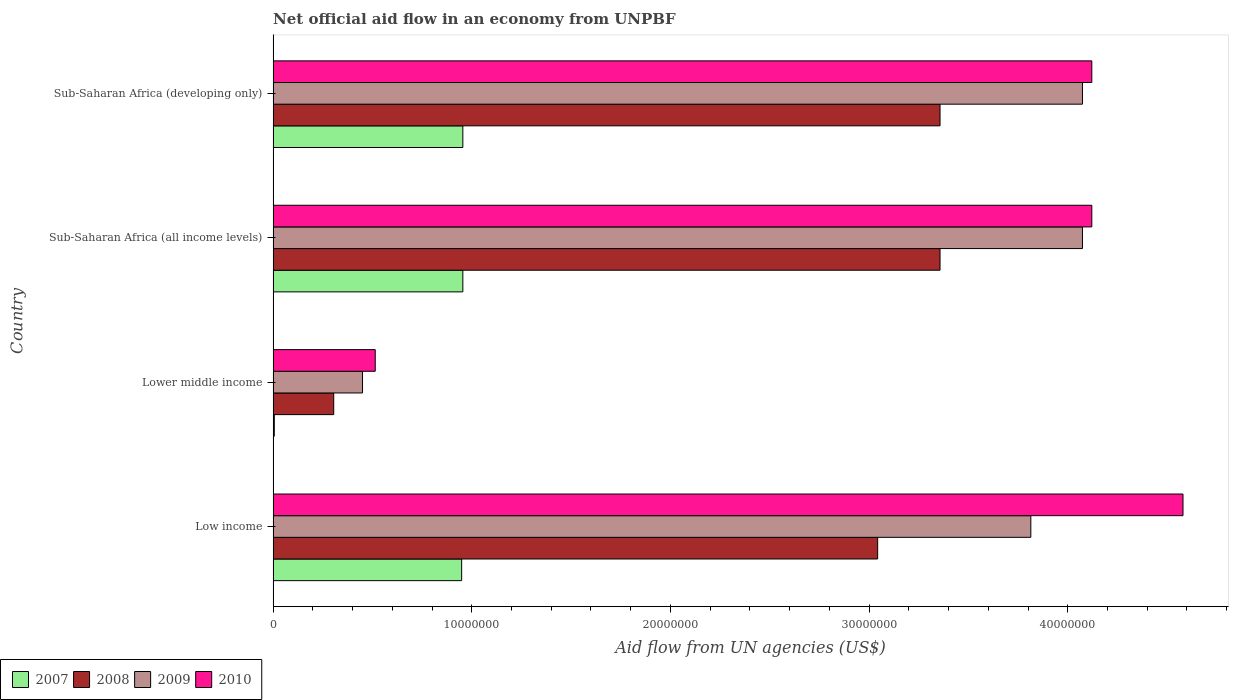How many different coloured bars are there?
Ensure brevity in your answer.  4. How many groups of bars are there?
Provide a short and direct response. 4. Are the number of bars per tick equal to the number of legend labels?
Your answer should be very brief. Yes. Are the number of bars on each tick of the Y-axis equal?
Your answer should be compact. Yes. How many bars are there on the 1st tick from the top?
Make the answer very short. 4. How many bars are there on the 2nd tick from the bottom?
Ensure brevity in your answer.  4. What is the label of the 4th group of bars from the top?
Offer a very short reply. Low income. In how many cases, is the number of bars for a given country not equal to the number of legend labels?
Your answer should be compact. 0. What is the net official aid flow in 2009 in Sub-Saharan Africa (all income levels)?
Offer a terse response. 4.07e+07. Across all countries, what is the maximum net official aid flow in 2010?
Ensure brevity in your answer.  4.58e+07. Across all countries, what is the minimum net official aid flow in 2008?
Offer a very short reply. 3.05e+06. In which country was the net official aid flow in 2008 maximum?
Provide a succinct answer. Sub-Saharan Africa (all income levels). In which country was the net official aid flow in 2008 minimum?
Offer a terse response. Lower middle income. What is the total net official aid flow in 2009 in the graph?
Offer a terse response. 1.24e+08. What is the difference between the net official aid flow in 2007 in Lower middle income and that in Sub-Saharan Africa (developing only)?
Make the answer very short. -9.49e+06. What is the difference between the net official aid flow in 2007 in Lower middle income and the net official aid flow in 2009 in Low income?
Offer a very short reply. -3.81e+07. What is the average net official aid flow in 2010 per country?
Offer a very short reply. 3.33e+07. What is the difference between the net official aid flow in 2009 and net official aid flow in 2007 in Lower middle income?
Make the answer very short. 4.44e+06. In how many countries, is the net official aid flow in 2010 greater than 40000000 US$?
Provide a short and direct response. 3. What is the ratio of the net official aid flow in 2008 in Sub-Saharan Africa (all income levels) to that in Sub-Saharan Africa (developing only)?
Your response must be concise. 1. Is the net official aid flow in 2010 in Sub-Saharan Africa (all income levels) less than that in Sub-Saharan Africa (developing only)?
Ensure brevity in your answer.  No. What is the difference between the highest and the lowest net official aid flow in 2009?
Your answer should be very brief. 3.62e+07. In how many countries, is the net official aid flow in 2008 greater than the average net official aid flow in 2008 taken over all countries?
Give a very brief answer. 3. Is it the case that in every country, the sum of the net official aid flow in 2007 and net official aid flow in 2008 is greater than the sum of net official aid flow in 2009 and net official aid flow in 2010?
Keep it short and to the point. No. Is it the case that in every country, the sum of the net official aid flow in 2010 and net official aid flow in 2007 is greater than the net official aid flow in 2008?
Offer a very short reply. Yes. How many bars are there?
Give a very brief answer. 16. Are all the bars in the graph horizontal?
Ensure brevity in your answer.  Yes. What is the difference between two consecutive major ticks on the X-axis?
Offer a terse response. 1.00e+07. Are the values on the major ticks of X-axis written in scientific E-notation?
Keep it short and to the point. No. Does the graph contain grids?
Give a very brief answer. No. What is the title of the graph?
Your answer should be very brief. Net official aid flow in an economy from UNPBF. What is the label or title of the X-axis?
Provide a succinct answer. Aid flow from UN agencies (US$). What is the Aid flow from UN agencies (US$) of 2007 in Low income?
Offer a terse response. 9.49e+06. What is the Aid flow from UN agencies (US$) in 2008 in Low income?
Provide a short and direct response. 3.04e+07. What is the Aid flow from UN agencies (US$) of 2009 in Low income?
Provide a succinct answer. 3.81e+07. What is the Aid flow from UN agencies (US$) of 2010 in Low income?
Make the answer very short. 4.58e+07. What is the Aid flow from UN agencies (US$) in 2007 in Lower middle income?
Your answer should be very brief. 6.00e+04. What is the Aid flow from UN agencies (US$) in 2008 in Lower middle income?
Keep it short and to the point. 3.05e+06. What is the Aid flow from UN agencies (US$) in 2009 in Lower middle income?
Offer a very short reply. 4.50e+06. What is the Aid flow from UN agencies (US$) in 2010 in Lower middle income?
Offer a terse response. 5.14e+06. What is the Aid flow from UN agencies (US$) of 2007 in Sub-Saharan Africa (all income levels)?
Keep it short and to the point. 9.55e+06. What is the Aid flow from UN agencies (US$) in 2008 in Sub-Saharan Africa (all income levels)?
Make the answer very short. 3.36e+07. What is the Aid flow from UN agencies (US$) of 2009 in Sub-Saharan Africa (all income levels)?
Give a very brief answer. 4.07e+07. What is the Aid flow from UN agencies (US$) in 2010 in Sub-Saharan Africa (all income levels)?
Your answer should be compact. 4.12e+07. What is the Aid flow from UN agencies (US$) of 2007 in Sub-Saharan Africa (developing only)?
Your answer should be compact. 9.55e+06. What is the Aid flow from UN agencies (US$) in 2008 in Sub-Saharan Africa (developing only)?
Your response must be concise. 3.36e+07. What is the Aid flow from UN agencies (US$) of 2009 in Sub-Saharan Africa (developing only)?
Provide a short and direct response. 4.07e+07. What is the Aid flow from UN agencies (US$) of 2010 in Sub-Saharan Africa (developing only)?
Make the answer very short. 4.12e+07. Across all countries, what is the maximum Aid flow from UN agencies (US$) in 2007?
Ensure brevity in your answer.  9.55e+06. Across all countries, what is the maximum Aid flow from UN agencies (US$) of 2008?
Your answer should be very brief. 3.36e+07. Across all countries, what is the maximum Aid flow from UN agencies (US$) of 2009?
Your answer should be compact. 4.07e+07. Across all countries, what is the maximum Aid flow from UN agencies (US$) in 2010?
Give a very brief answer. 4.58e+07. Across all countries, what is the minimum Aid flow from UN agencies (US$) in 2008?
Keep it short and to the point. 3.05e+06. Across all countries, what is the minimum Aid flow from UN agencies (US$) of 2009?
Offer a very short reply. 4.50e+06. Across all countries, what is the minimum Aid flow from UN agencies (US$) of 2010?
Keep it short and to the point. 5.14e+06. What is the total Aid flow from UN agencies (US$) of 2007 in the graph?
Ensure brevity in your answer.  2.86e+07. What is the total Aid flow from UN agencies (US$) of 2008 in the graph?
Provide a succinct answer. 1.01e+08. What is the total Aid flow from UN agencies (US$) of 2009 in the graph?
Offer a terse response. 1.24e+08. What is the total Aid flow from UN agencies (US$) in 2010 in the graph?
Provide a succinct answer. 1.33e+08. What is the difference between the Aid flow from UN agencies (US$) of 2007 in Low income and that in Lower middle income?
Your response must be concise. 9.43e+06. What is the difference between the Aid flow from UN agencies (US$) of 2008 in Low income and that in Lower middle income?
Offer a very short reply. 2.74e+07. What is the difference between the Aid flow from UN agencies (US$) of 2009 in Low income and that in Lower middle income?
Ensure brevity in your answer.  3.36e+07. What is the difference between the Aid flow from UN agencies (US$) in 2010 in Low income and that in Lower middle income?
Make the answer very short. 4.07e+07. What is the difference between the Aid flow from UN agencies (US$) in 2008 in Low income and that in Sub-Saharan Africa (all income levels)?
Provide a succinct answer. -3.14e+06. What is the difference between the Aid flow from UN agencies (US$) of 2009 in Low income and that in Sub-Saharan Africa (all income levels)?
Ensure brevity in your answer.  -2.60e+06. What is the difference between the Aid flow from UN agencies (US$) of 2010 in Low income and that in Sub-Saharan Africa (all income levels)?
Your answer should be very brief. 4.59e+06. What is the difference between the Aid flow from UN agencies (US$) in 2007 in Low income and that in Sub-Saharan Africa (developing only)?
Give a very brief answer. -6.00e+04. What is the difference between the Aid flow from UN agencies (US$) in 2008 in Low income and that in Sub-Saharan Africa (developing only)?
Provide a succinct answer. -3.14e+06. What is the difference between the Aid flow from UN agencies (US$) of 2009 in Low income and that in Sub-Saharan Africa (developing only)?
Keep it short and to the point. -2.60e+06. What is the difference between the Aid flow from UN agencies (US$) in 2010 in Low income and that in Sub-Saharan Africa (developing only)?
Provide a short and direct response. 4.59e+06. What is the difference between the Aid flow from UN agencies (US$) of 2007 in Lower middle income and that in Sub-Saharan Africa (all income levels)?
Provide a succinct answer. -9.49e+06. What is the difference between the Aid flow from UN agencies (US$) of 2008 in Lower middle income and that in Sub-Saharan Africa (all income levels)?
Ensure brevity in your answer.  -3.05e+07. What is the difference between the Aid flow from UN agencies (US$) in 2009 in Lower middle income and that in Sub-Saharan Africa (all income levels)?
Make the answer very short. -3.62e+07. What is the difference between the Aid flow from UN agencies (US$) in 2010 in Lower middle income and that in Sub-Saharan Africa (all income levels)?
Your answer should be very brief. -3.61e+07. What is the difference between the Aid flow from UN agencies (US$) of 2007 in Lower middle income and that in Sub-Saharan Africa (developing only)?
Provide a short and direct response. -9.49e+06. What is the difference between the Aid flow from UN agencies (US$) in 2008 in Lower middle income and that in Sub-Saharan Africa (developing only)?
Your response must be concise. -3.05e+07. What is the difference between the Aid flow from UN agencies (US$) in 2009 in Lower middle income and that in Sub-Saharan Africa (developing only)?
Ensure brevity in your answer.  -3.62e+07. What is the difference between the Aid flow from UN agencies (US$) of 2010 in Lower middle income and that in Sub-Saharan Africa (developing only)?
Provide a succinct answer. -3.61e+07. What is the difference between the Aid flow from UN agencies (US$) in 2007 in Low income and the Aid flow from UN agencies (US$) in 2008 in Lower middle income?
Keep it short and to the point. 6.44e+06. What is the difference between the Aid flow from UN agencies (US$) in 2007 in Low income and the Aid flow from UN agencies (US$) in 2009 in Lower middle income?
Offer a very short reply. 4.99e+06. What is the difference between the Aid flow from UN agencies (US$) in 2007 in Low income and the Aid flow from UN agencies (US$) in 2010 in Lower middle income?
Give a very brief answer. 4.35e+06. What is the difference between the Aid flow from UN agencies (US$) in 2008 in Low income and the Aid flow from UN agencies (US$) in 2009 in Lower middle income?
Provide a succinct answer. 2.59e+07. What is the difference between the Aid flow from UN agencies (US$) of 2008 in Low income and the Aid flow from UN agencies (US$) of 2010 in Lower middle income?
Your response must be concise. 2.53e+07. What is the difference between the Aid flow from UN agencies (US$) of 2009 in Low income and the Aid flow from UN agencies (US$) of 2010 in Lower middle income?
Give a very brief answer. 3.30e+07. What is the difference between the Aid flow from UN agencies (US$) in 2007 in Low income and the Aid flow from UN agencies (US$) in 2008 in Sub-Saharan Africa (all income levels)?
Offer a terse response. -2.41e+07. What is the difference between the Aid flow from UN agencies (US$) of 2007 in Low income and the Aid flow from UN agencies (US$) of 2009 in Sub-Saharan Africa (all income levels)?
Make the answer very short. -3.12e+07. What is the difference between the Aid flow from UN agencies (US$) in 2007 in Low income and the Aid flow from UN agencies (US$) in 2010 in Sub-Saharan Africa (all income levels)?
Provide a short and direct response. -3.17e+07. What is the difference between the Aid flow from UN agencies (US$) of 2008 in Low income and the Aid flow from UN agencies (US$) of 2009 in Sub-Saharan Africa (all income levels)?
Give a very brief answer. -1.03e+07. What is the difference between the Aid flow from UN agencies (US$) in 2008 in Low income and the Aid flow from UN agencies (US$) in 2010 in Sub-Saharan Africa (all income levels)?
Your answer should be compact. -1.08e+07. What is the difference between the Aid flow from UN agencies (US$) of 2009 in Low income and the Aid flow from UN agencies (US$) of 2010 in Sub-Saharan Africa (all income levels)?
Your response must be concise. -3.07e+06. What is the difference between the Aid flow from UN agencies (US$) in 2007 in Low income and the Aid flow from UN agencies (US$) in 2008 in Sub-Saharan Africa (developing only)?
Your response must be concise. -2.41e+07. What is the difference between the Aid flow from UN agencies (US$) of 2007 in Low income and the Aid flow from UN agencies (US$) of 2009 in Sub-Saharan Africa (developing only)?
Provide a short and direct response. -3.12e+07. What is the difference between the Aid flow from UN agencies (US$) of 2007 in Low income and the Aid flow from UN agencies (US$) of 2010 in Sub-Saharan Africa (developing only)?
Your response must be concise. -3.17e+07. What is the difference between the Aid flow from UN agencies (US$) in 2008 in Low income and the Aid flow from UN agencies (US$) in 2009 in Sub-Saharan Africa (developing only)?
Your answer should be very brief. -1.03e+07. What is the difference between the Aid flow from UN agencies (US$) of 2008 in Low income and the Aid flow from UN agencies (US$) of 2010 in Sub-Saharan Africa (developing only)?
Provide a succinct answer. -1.08e+07. What is the difference between the Aid flow from UN agencies (US$) of 2009 in Low income and the Aid flow from UN agencies (US$) of 2010 in Sub-Saharan Africa (developing only)?
Provide a short and direct response. -3.07e+06. What is the difference between the Aid flow from UN agencies (US$) of 2007 in Lower middle income and the Aid flow from UN agencies (US$) of 2008 in Sub-Saharan Africa (all income levels)?
Your answer should be compact. -3.35e+07. What is the difference between the Aid flow from UN agencies (US$) in 2007 in Lower middle income and the Aid flow from UN agencies (US$) in 2009 in Sub-Saharan Africa (all income levels)?
Your answer should be compact. -4.07e+07. What is the difference between the Aid flow from UN agencies (US$) of 2007 in Lower middle income and the Aid flow from UN agencies (US$) of 2010 in Sub-Saharan Africa (all income levels)?
Your answer should be very brief. -4.12e+07. What is the difference between the Aid flow from UN agencies (US$) of 2008 in Lower middle income and the Aid flow from UN agencies (US$) of 2009 in Sub-Saharan Africa (all income levels)?
Keep it short and to the point. -3.77e+07. What is the difference between the Aid flow from UN agencies (US$) in 2008 in Lower middle income and the Aid flow from UN agencies (US$) in 2010 in Sub-Saharan Africa (all income levels)?
Provide a succinct answer. -3.82e+07. What is the difference between the Aid flow from UN agencies (US$) of 2009 in Lower middle income and the Aid flow from UN agencies (US$) of 2010 in Sub-Saharan Africa (all income levels)?
Your answer should be compact. -3.67e+07. What is the difference between the Aid flow from UN agencies (US$) of 2007 in Lower middle income and the Aid flow from UN agencies (US$) of 2008 in Sub-Saharan Africa (developing only)?
Offer a very short reply. -3.35e+07. What is the difference between the Aid flow from UN agencies (US$) of 2007 in Lower middle income and the Aid flow from UN agencies (US$) of 2009 in Sub-Saharan Africa (developing only)?
Offer a very short reply. -4.07e+07. What is the difference between the Aid flow from UN agencies (US$) in 2007 in Lower middle income and the Aid flow from UN agencies (US$) in 2010 in Sub-Saharan Africa (developing only)?
Make the answer very short. -4.12e+07. What is the difference between the Aid flow from UN agencies (US$) in 2008 in Lower middle income and the Aid flow from UN agencies (US$) in 2009 in Sub-Saharan Africa (developing only)?
Your answer should be very brief. -3.77e+07. What is the difference between the Aid flow from UN agencies (US$) in 2008 in Lower middle income and the Aid flow from UN agencies (US$) in 2010 in Sub-Saharan Africa (developing only)?
Provide a succinct answer. -3.82e+07. What is the difference between the Aid flow from UN agencies (US$) of 2009 in Lower middle income and the Aid flow from UN agencies (US$) of 2010 in Sub-Saharan Africa (developing only)?
Make the answer very short. -3.67e+07. What is the difference between the Aid flow from UN agencies (US$) in 2007 in Sub-Saharan Africa (all income levels) and the Aid flow from UN agencies (US$) in 2008 in Sub-Saharan Africa (developing only)?
Provide a succinct answer. -2.40e+07. What is the difference between the Aid flow from UN agencies (US$) of 2007 in Sub-Saharan Africa (all income levels) and the Aid flow from UN agencies (US$) of 2009 in Sub-Saharan Africa (developing only)?
Provide a short and direct response. -3.12e+07. What is the difference between the Aid flow from UN agencies (US$) in 2007 in Sub-Saharan Africa (all income levels) and the Aid flow from UN agencies (US$) in 2010 in Sub-Saharan Africa (developing only)?
Provide a succinct answer. -3.17e+07. What is the difference between the Aid flow from UN agencies (US$) in 2008 in Sub-Saharan Africa (all income levels) and the Aid flow from UN agencies (US$) in 2009 in Sub-Saharan Africa (developing only)?
Provide a succinct answer. -7.17e+06. What is the difference between the Aid flow from UN agencies (US$) in 2008 in Sub-Saharan Africa (all income levels) and the Aid flow from UN agencies (US$) in 2010 in Sub-Saharan Africa (developing only)?
Your response must be concise. -7.64e+06. What is the difference between the Aid flow from UN agencies (US$) in 2009 in Sub-Saharan Africa (all income levels) and the Aid flow from UN agencies (US$) in 2010 in Sub-Saharan Africa (developing only)?
Offer a very short reply. -4.70e+05. What is the average Aid flow from UN agencies (US$) in 2007 per country?
Make the answer very short. 7.16e+06. What is the average Aid flow from UN agencies (US$) in 2008 per country?
Keep it short and to the point. 2.52e+07. What is the average Aid flow from UN agencies (US$) of 2009 per country?
Keep it short and to the point. 3.10e+07. What is the average Aid flow from UN agencies (US$) of 2010 per country?
Make the answer very short. 3.33e+07. What is the difference between the Aid flow from UN agencies (US$) of 2007 and Aid flow from UN agencies (US$) of 2008 in Low income?
Your answer should be very brief. -2.09e+07. What is the difference between the Aid flow from UN agencies (US$) of 2007 and Aid flow from UN agencies (US$) of 2009 in Low income?
Make the answer very short. -2.86e+07. What is the difference between the Aid flow from UN agencies (US$) of 2007 and Aid flow from UN agencies (US$) of 2010 in Low income?
Ensure brevity in your answer.  -3.63e+07. What is the difference between the Aid flow from UN agencies (US$) in 2008 and Aid flow from UN agencies (US$) in 2009 in Low income?
Offer a very short reply. -7.71e+06. What is the difference between the Aid flow from UN agencies (US$) of 2008 and Aid flow from UN agencies (US$) of 2010 in Low income?
Your response must be concise. -1.54e+07. What is the difference between the Aid flow from UN agencies (US$) of 2009 and Aid flow from UN agencies (US$) of 2010 in Low income?
Offer a very short reply. -7.66e+06. What is the difference between the Aid flow from UN agencies (US$) in 2007 and Aid flow from UN agencies (US$) in 2008 in Lower middle income?
Give a very brief answer. -2.99e+06. What is the difference between the Aid flow from UN agencies (US$) of 2007 and Aid flow from UN agencies (US$) of 2009 in Lower middle income?
Give a very brief answer. -4.44e+06. What is the difference between the Aid flow from UN agencies (US$) in 2007 and Aid flow from UN agencies (US$) in 2010 in Lower middle income?
Your answer should be compact. -5.08e+06. What is the difference between the Aid flow from UN agencies (US$) of 2008 and Aid flow from UN agencies (US$) of 2009 in Lower middle income?
Make the answer very short. -1.45e+06. What is the difference between the Aid flow from UN agencies (US$) in 2008 and Aid flow from UN agencies (US$) in 2010 in Lower middle income?
Offer a very short reply. -2.09e+06. What is the difference between the Aid flow from UN agencies (US$) of 2009 and Aid flow from UN agencies (US$) of 2010 in Lower middle income?
Your answer should be very brief. -6.40e+05. What is the difference between the Aid flow from UN agencies (US$) of 2007 and Aid flow from UN agencies (US$) of 2008 in Sub-Saharan Africa (all income levels)?
Offer a terse response. -2.40e+07. What is the difference between the Aid flow from UN agencies (US$) of 2007 and Aid flow from UN agencies (US$) of 2009 in Sub-Saharan Africa (all income levels)?
Give a very brief answer. -3.12e+07. What is the difference between the Aid flow from UN agencies (US$) of 2007 and Aid flow from UN agencies (US$) of 2010 in Sub-Saharan Africa (all income levels)?
Give a very brief answer. -3.17e+07. What is the difference between the Aid flow from UN agencies (US$) of 2008 and Aid flow from UN agencies (US$) of 2009 in Sub-Saharan Africa (all income levels)?
Ensure brevity in your answer.  -7.17e+06. What is the difference between the Aid flow from UN agencies (US$) of 2008 and Aid flow from UN agencies (US$) of 2010 in Sub-Saharan Africa (all income levels)?
Offer a very short reply. -7.64e+06. What is the difference between the Aid flow from UN agencies (US$) of 2009 and Aid flow from UN agencies (US$) of 2010 in Sub-Saharan Africa (all income levels)?
Give a very brief answer. -4.70e+05. What is the difference between the Aid flow from UN agencies (US$) in 2007 and Aid flow from UN agencies (US$) in 2008 in Sub-Saharan Africa (developing only)?
Ensure brevity in your answer.  -2.40e+07. What is the difference between the Aid flow from UN agencies (US$) of 2007 and Aid flow from UN agencies (US$) of 2009 in Sub-Saharan Africa (developing only)?
Your response must be concise. -3.12e+07. What is the difference between the Aid flow from UN agencies (US$) of 2007 and Aid flow from UN agencies (US$) of 2010 in Sub-Saharan Africa (developing only)?
Offer a terse response. -3.17e+07. What is the difference between the Aid flow from UN agencies (US$) in 2008 and Aid flow from UN agencies (US$) in 2009 in Sub-Saharan Africa (developing only)?
Offer a very short reply. -7.17e+06. What is the difference between the Aid flow from UN agencies (US$) in 2008 and Aid flow from UN agencies (US$) in 2010 in Sub-Saharan Africa (developing only)?
Provide a succinct answer. -7.64e+06. What is the difference between the Aid flow from UN agencies (US$) in 2009 and Aid flow from UN agencies (US$) in 2010 in Sub-Saharan Africa (developing only)?
Your answer should be compact. -4.70e+05. What is the ratio of the Aid flow from UN agencies (US$) in 2007 in Low income to that in Lower middle income?
Offer a terse response. 158.17. What is the ratio of the Aid flow from UN agencies (US$) in 2008 in Low income to that in Lower middle income?
Your response must be concise. 9.98. What is the ratio of the Aid flow from UN agencies (US$) in 2009 in Low income to that in Lower middle income?
Provide a short and direct response. 8.48. What is the ratio of the Aid flow from UN agencies (US$) of 2010 in Low income to that in Lower middle income?
Provide a short and direct response. 8.91. What is the ratio of the Aid flow from UN agencies (US$) of 2008 in Low income to that in Sub-Saharan Africa (all income levels)?
Ensure brevity in your answer.  0.91. What is the ratio of the Aid flow from UN agencies (US$) in 2009 in Low income to that in Sub-Saharan Africa (all income levels)?
Ensure brevity in your answer.  0.94. What is the ratio of the Aid flow from UN agencies (US$) in 2010 in Low income to that in Sub-Saharan Africa (all income levels)?
Provide a succinct answer. 1.11. What is the ratio of the Aid flow from UN agencies (US$) of 2008 in Low income to that in Sub-Saharan Africa (developing only)?
Offer a terse response. 0.91. What is the ratio of the Aid flow from UN agencies (US$) of 2009 in Low income to that in Sub-Saharan Africa (developing only)?
Provide a succinct answer. 0.94. What is the ratio of the Aid flow from UN agencies (US$) of 2010 in Low income to that in Sub-Saharan Africa (developing only)?
Give a very brief answer. 1.11. What is the ratio of the Aid flow from UN agencies (US$) of 2007 in Lower middle income to that in Sub-Saharan Africa (all income levels)?
Your answer should be very brief. 0.01. What is the ratio of the Aid flow from UN agencies (US$) in 2008 in Lower middle income to that in Sub-Saharan Africa (all income levels)?
Provide a short and direct response. 0.09. What is the ratio of the Aid flow from UN agencies (US$) of 2009 in Lower middle income to that in Sub-Saharan Africa (all income levels)?
Provide a succinct answer. 0.11. What is the ratio of the Aid flow from UN agencies (US$) of 2010 in Lower middle income to that in Sub-Saharan Africa (all income levels)?
Offer a very short reply. 0.12. What is the ratio of the Aid flow from UN agencies (US$) in 2007 in Lower middle income to that in Sub-Saharan Africa (developing only)?
Offer a very short reply. 0.01. What is the ratio of the Aid flow from UN agencies (US$) of 2008 in Lower middle income to that in Sub-Saharan Africa (developing only)?
Your answer should be very brief. 0.09. What is the ratio of the Aid flow from UN agencies (US$) in 2009 in Lower middle income to that in Sub-Saharan Africa (developing only)?
Keep it short and to the point. 0.11. What is the ratio of the Aid flow from UN agencies (US$) of 2010 in Lower middle income to that in Sub-Saharan Africa (developing only)?
Provide a succinct answer. 0.12. What is the ratio of the Aid flow from UN agencies (US$) in 2008 in Sub-Saharan Africa (all income levels) to that in Sub-Saharan Africa (developing only)?
Your answer should be very brief. 1. What is the ratio of the Aid flow from UN agencies (US$) in 2010 in Sub-Saharan Africa (all income levels) to that in Sub-Saharan Africa (developing only)?
Give a very brief answer. 1. What is the difference between the highest and the second highest Aid flow from UN agencies (US$) of 2009?
Keep it short and to the point. 0. What is the difference between the highest and the second highest Aid flow from UN agencies (US$) of 2010?
Provide a short and direct response. 4.59e+06. What is the difference between the highest and the lowest Aid flow from UN agencies (US$) in 2007?
Your answer should be compact. 9.49e+06. What is the difference between the highest and the lowest Aid flow from UN agencies (US$) in 2008?
Your response must be concise. 3.05e+07. What is the difference between the highest and the lowest Aid flow from UN agencies (US$) of 2009?
Keep it short and to the point. 3.62e+07. What is the difference between the highest and the lowest Aid flow from UN agencies (US$) in 2010?
Your response must be concise. 4.07e+07. 